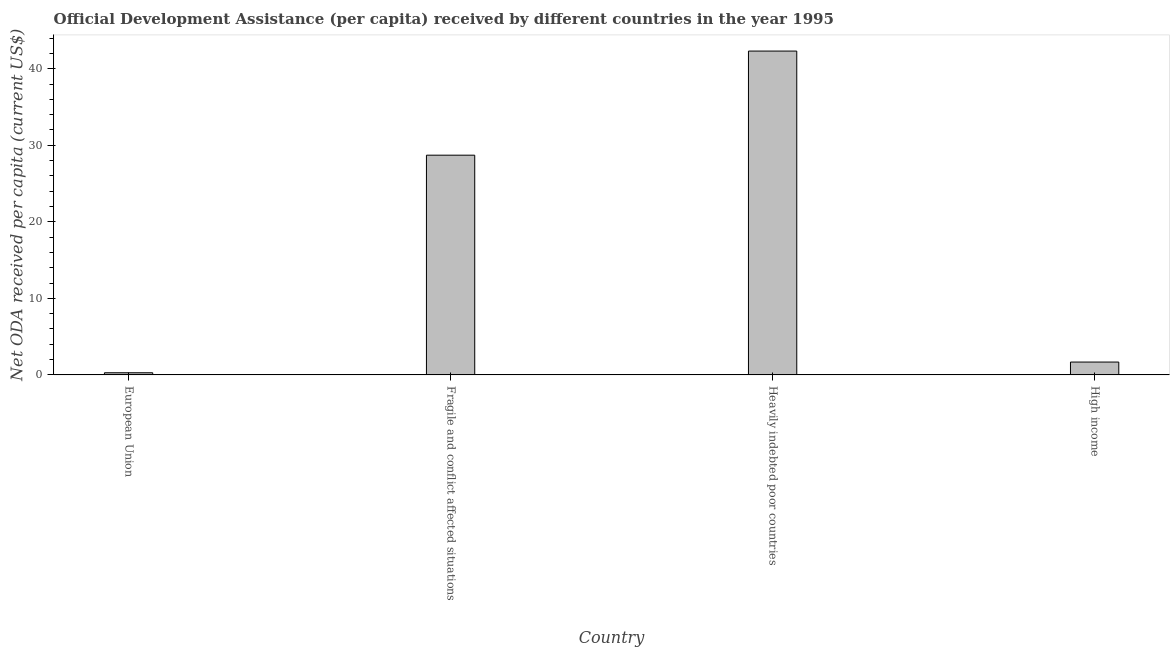What is the title of the graph?
Ensure brevity in your answer.  Official Development Assistance (per capita) received by different countries in the year 1995. What is the label or title of the X-axis?
Keep it short and to the point. Country. What is the label or title of the Y-axis?
Provide a succinct answer. Net ODA received per capita (current US$). What is the net oda received per capita in Heavily indebted poor countries?
Provide a short and direct response. 42.31. Across all countries, what is the maximum net oda received per capita?
Your answer should be very brief. 42.31. Across all countries, what is the minimum net oda received per capita?
Offer a very short reply. 0.28. In which country was the net oda received per capita maximum?
Provide a succinct answer. Heavily indebted poor countries. What is the sum of the net oda received per capita?
Your response must be concise. 72.98. What is the difference between the net oda received per capita in Fragile and conflict affected situations and Heavily indebted poor countries?
Keep it short and to the point. -13.6. What is the average net oda received per capita per country?
Give a very brief answer. 18.25. What is the median net oda received per capita?
Your response must be concise. 15.19. What is the ratio of the net oda received per capita in Fragile and conflict affected situations to that in Heavily indebted poor countries?
Provide a succinct answer. 0.68. What is the difference between the highest and the second highest net oda received per capita?
Your answer should be compact. 13.6. What is the difference between the highest and the lowest net oda received per capita?
Ensure brevity in your answer.  42.03. In how many countries, is the net oda received per capita greater than the average net oda received per capita taken over all countries?
Offer a terse response. 2. How many bars are there?
Your response must be concise. 4. Are all the bars in the graph horizontal?
Your answer should be very brief. No. How many countries are there in the graph?
Your answer should be compact. 4. What is the difference between two consecutive major ticks on the Y-axis?
Your answer should be very brief. 10. What is the Net ODA received per capita (current US$) in European Union?
Keep it short and to the point. 0.28. What is the Net ODA received per capita (current US$) of Fragile and conflict affected situations?
Offer a very short reply. 28.71. What is the Net ODA received per capita (current US$) in Heavily indebted poor countries?
Offer a very short reply. 42.31. What is the Net ODA received per capita (current US$) of High income?
Give a very brief answer. 1.68. What is the difference between the Net ODA received per capita (current US$) in European Union and Fragile and conflict affected situations?
Offer a terse response. -28.43. What is the difference between the Net ODA received per capita (current US$) in European Union and Heavily indebted poor countries?
Your response must be concise. -42.03. What is the difference between the Net ODA received per capita (current US$) in European Union and High income?
Provide a short and direct response. -1.4. What is the difference between the Net ODA received per capita (current US$) in Fragile and conflict affected situations and Heavily indebted poor countries?
Your answer should be compact. -13.6. What is the difference between the Net ODA received per capita (current US$) in Fragile and conflict affected situations and High income?
Provide a short and direct response. 27.03. What is the difference between the Net ODA received per capita (current US$) in Heavily indebted poor countries and High income?
Give a very brief answer. 40.63. What is the ratio of the Net ODA received per capita (current US$) in European Union to that in Heavily indebted poor countries?
Provide a succinct answer. 0.01. What is the ratio of the Net ODA received per capita (current US$) in European Union to that in High income?
Make the answer very short. 0.17. What is the ratio of the Net ODA received per capita (current US$) in Fragile and conflict affected situations to that in Heavily indebted poor countries?
Offer a very short reply. 0.68. What is the ratio of the Net ODA received per capita (current US$) in Fragile and conflict affected situations to that in High income?
Your answer should be very brief. 17.09. What is the ratio of the Net ODA received per capita (current US$) in Heavily indebted poor countries to that in High income?
Provide a succinct answer. 25.18. 